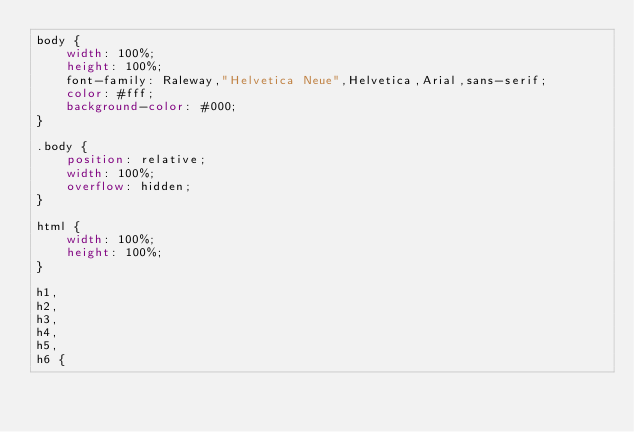<code> <loc_0><loc_0><loc_500><loc_500><_CSS_>body {
    width: 100%;
    height: 100%;
    font-family: Raleway,"Helvetica Neue",Helvetica,Arial,sans-serif;
    color: #fff;
    background-color: #000;
}

.body {
    position: relative;
    width: 100%;
    overflow: hidden;
}

html {
    width: 100%;
    height: 100%;
}

h1,
h2,
h3,
h4,
h5,
h6 {</code> 